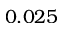<formula> <loc_0><loc_0><loc_500><loc_500>0 . 0 2 5</formula> 